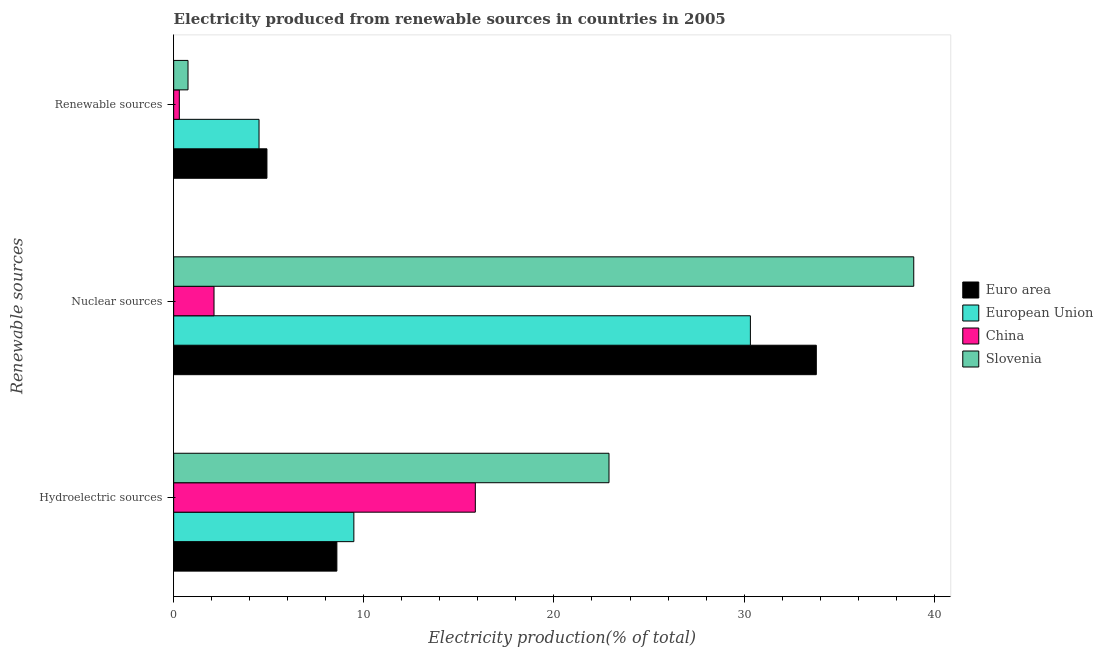How many different coloured bars are there?
Offer a very short reply. 4. How many groups of bars are there?
Provide a succinct answer. 3. How many bars are there on the 2nd tick from the top?
Provide a succinct answer. 4. What is the label of the 2nd group of bars from the top?
Your response must be concise. Nuclear sources. What is the percentage of electricity produced by renewable sources in Slovenia?
Your answer should be very brief. 0.75. Across all countries, what is the maximum percentage of electricity produced by nuclear sources?
Provide a succinct answer. 38.92. Across all countries, what is the minimum percentage of electricity produced by hydroelectric sources?
Ensure brevity in your answer.  8.58. In which country was the percentage of electricity produced by hydroelectric sources maximum?
Ensure brevity in your answer.  Slovenia. What is the total percentage of electricity produced by hydroelectric sources in the graph?
Your answer should be very brief. 56.82. What is the difference between the percentage of electricity produced by nuclear sources in Euro area and that in Slovenia?
Offer a very short reply. -5.12. What is the difference between the percentage of electricity produced by nuclear sources in European Union and the percentage of electricity produced by hydroelectric sources in China?
Make the answer very short. 14.47. What is the average percentage of electricity produced by renewable sources per country?
Your answer should be compact. 2.61. What is the difference between the percentage of electricity produced by renewable sources and percentage of electricity produced by nuclear sources in Slovenia?
Provide a succinct answer. -38.17. What is the ratio of the percentage of electricity produced by nuclear sources in Euro area to that in Slovenia?
Give a very brief answer. 0.87. What is the difference between the highest and the second highest percentage of electricity produced by renewable sources?
Give a very brief answer. 0.42. What is the difference between the highest and the lowest percentage of electricity produced by nuclear sources?
Your answer should be very brief. 36.8. What does the 1st bar from the top in Nuclear sources represents?
Your answer should be compact. Slovenia. How many bars are there?
Your response must be concise. 12. Are all the bars in the graph horizontal?
Your answer should be compact. Yes. What is the difference between two consecutive major ticks on the X-axis?
Provide a short and direct response. 10. Does the graph contain any zero values?
Give a very brief answer. No. How are the legend labels stacked?
Ensure brevity in your answer.  Vertical. What is the title of the graph?
Offer a very short reply. Electricity produced from renewable sources in countries in 2005. What is the label or title of the Y-axis?
Offer a terse response. Renewable sources. What is the Electricity production(% of total) in Euro area in Hydroelectric sources?
Make the answer very short. 8.58. What is the Electricity production(% of total) in European Union in Hydroelectric sources?
Provide a succinct answer. 9.48. What is the Electricity production(% of total) of China in Hydroelectric sources?
Your answer should be compact. 15.86. What is the Electricity production(% of total) in Slovenia in Hydroelectric sources?
Your answer should be very brief. 22.89. What is the Electricity production(% of total) of Euro area in Nuclear sources?
Offer a very short reply. 33.8. What is the Electricity production(% of total) in European Union in Nuclear sources?
Your answer should be compact. 30.33. What is the Electricity production(% of total) in China in Nuclear sources?
Keep it short and to the point. 2.12. What is the Electricity production(% of total) in Slovenia in Nuclear sources?
Your answer should be compact. 38.92. What is the Electricity production(% of total) of Euro area in Renewable sources?
Your answer should be very brief. 4.91. What is the Electricity production(% of total) of European Union in Renewable sources?
Offer a very short reply. 4.49. What is the Electricity production(% of total) of China in Renewable sources?
Your answer should be very brief. 0.3. What is the Electricity production(% of total) of Slovenia in Renewable sources?
Provide a short and direct response. 0.75. Across all Renewable sources, what is the maximum Electricity production(% of total) of Euro area?
Provide a short and direct response. 33.8. Across all Renewable sources, what is the maximum Electricity production(% of total) of European Union?
Ensure brevity in your answer.  30.33. Across all Renewable sources, what is the maximum Electricity production(% of total) in China?
Give a very brief answer. 15.86. Across all Renewable sources, what is the maximum Electricity production(% of total) in Slovenia?
Offer a terse response. 38.92. Across all Renewable sources, what is the minimum Electricity production(% of total) of Euro area?
Offer a terse response. 4.91. Across all Renewable sources, what is the minimum Electricity production(% of total) of European Union?
Ensure brevity in your answer.  4.49. Across all Renewable sources, what is the minimum Electricity production(% of total) in China?
Your answer should be compact. 0.3. Across all Renewable sources, what is the minimum Electricity production(% of total) of Slovenia?
Make the answer very short. 0.75. What is the total Electricity production(% of total) in Euro area in the graph?
Offer a very short reply. 47.29. What is the total Electricity production(% of total) in European Union in the graph?
Ensure brevity in your answer.  44.3. What is the total Electricity production(% of total) of China in the graph?
Provide a succinct answer. 18.28. What is the total Electricity production(% of total) in Slovenia in the graph?
Provide a succinct answer. 62.57. What is the difference between the Electricity production(% of total) in Euro area in Hydroelectric sources and that in Nuclear sources?
Your response must be concise. -25.22. What is the difference between the Electricity production(% of total) in European Union in Hydroelectric sources and that in Nuclear sources?
Provide a short and direct response. -20.85. What is the difference between the Electricity production(% of total) in China in Hydroelectric sources and that in Nuclear sources?
Your response must be concise. 13.74. What is the difference between the Electricity production(% of total) of Slovenia in Hydroelectric sources and that in Nuclear sources?
Ensure brevity in your answer.  -16.03. What is the difference between the Electricity production(% of total) of Euro area in Hydroelectric sources and that in Renewable sources?
Offer a terse response. 3.68. What is the difference between the Electricity production(% of total) of European Union in Hydroelectric sources and that in Renewable sources?
Your answer should be compact. 4.99. What is the difference between the Electricity production(% of total) of China in Hydroelectric sources and that in Renewable sources?
Keep it short and to the point. 15.57. What is the difference between the Electricity production(% of total) in Slovenia in Hydroelectric sources and that in Renewable sources?
Provide a succinct answer. 22.14. What is the difference between the Electricity production(% of total) in Euro area in Nuclear sources and that in Renewable sources?
Your answer should be very brief. 28.89. What is the difference between the Electricity production(% of total) of European Union in Nuclear sources and that in Renewable sources?
Your response must be concise. 25.84. What is the difference between the Electricity production(% of total) of China in Nuclear sources and that in Renewable sources?
Ensure brevity in your answer.  1.82. What is the difference between the Electricity production(% of total) in Slovenia in Nuclear sources and that in Renewable sources?
Offer a very short reply. 38.17. What is the difference between the Electricity production(% of total) of Euro area in Hydroelectric sources and the Electricity production(% of total) of European Union in Nuclear sources?
Keep it short and to the point. -21.75. What is the difference between the Electricity production(% of total) in Euro area in Hydroelectric sources and the Electricity production(% of total) in China in Nuclear sources?
Provide a short and direct response. 6.46. What is the difference between the Electricity production(% of total) in Euro area in Hydroelectric sources and the Electricity production(% of total) in Slovenia in Nuclear sources?
Offer a terse response. -30.34. What is the difference between the Electricity production(% of total) in European Union in Hydroelectric sources and the Electricity production(% of total) in China in Nuclear sources?
Keep it short and to the point. 7.36. What is the difference between the Electricity production(% of total) of European Union in Hydroelectric sources and the Electricity production(% of total) of Slovenia in Nuclear sources?
Offer a very short reply. -29.45. What is the difference between the Electricity production(% of total) of China in Hydroelectric sources and the Electricity production(% of total) of Slovenia in Nuclear sources?
Offer a terse response. -23.06. What is the difference between the Electricity production(% of total) of Euro area in Hydroelectric sources and the Electricity production(% of total) of European Union in Renewable sources?
Ensure brevity in your answer.  4.09. What is the difference between the Electricity production(% of total) of Euro area in Hydroelectric sources and the Electricity production(% of total) of China in Renewable sources?
Provide a short and direct response. 8.29. What is the difference between the Electricity production(% of total) in Euro area in Hydroelectric sources and the Electricity production(% of total) in Slovenia in Renewable sources?
Make the answer very short. 7.83. What is the difference between the Electricity production(% of total) in European Union in Hydroelectric sources and the Electricity production(% of total) in China in Renewable sources?
Your response must be concise. 9.18. What is the difference between the Electricity production(% of total) in European Union in Hydroelectric sources and the Electricity production(% of total) in Slovenia in Renewable sources?
Ensure brevity in your answer.  8.72. What is the difference between the Electricity production(% of total) of China in Hydroelectric sources and the Electricity production(% of total) of Slovenia in Renewable sources?
Give a very brief answer. 15.11. What is the difference between the Electricity production(% of total) of Euro area in Nuclear sources and the Electricity production(% of total) of European Union in Renewable sources?
Provide a succinct answer. 29.31. What is the difference between the Electricity production(% of total) in Euro area in Nuclear sources and the Electricity production(% of total) in China in Renewable sources?
Offer a terse response. 33.5. What is the difference between the Electricity production(% of total) in Euro area in Nuclear sources and the Electricity production(% of total) in Slovenia in Renewable sources?
Your answer should be compact. 33.04. What is the difference between the Electricity production(% of total) of European Union in Nuclear sources and the Electricity production(% of total) of China in Renewable sources?
Offer a very short reply. 30.03. What is the difference between the Electricity production(% of total) of European Union in Nuclear sources and the Electricity production(% of total) of Slovenia in Renewable sources?
Keep it short and to the point. 29.58. What is the difference between the Electricity production(% of total) of China in Nuclear sources and the Electricity production(% of total) of Slovenia in Renewable sources?
Give a very brief answer. 1.37. What is the average Electricity production(% of total) of Euro area per Renewable sources?
Give a very brief answer. 15.76. What is the average Electricity production(% of total) of European Union per Renewable sources?
Keep it short and to the point. 14.77. What is the average Electricity production(% of total) of China per Renewable sources?
Offer a very short reply. 6.09. What is the average Electricity production(% of total) in Slovenia per Renewable sources?
Offer a very short reply. 20.86. What is the difference between the Electricity production(% of total) in Euro area and Electricity production(% of total) in European Union in Hydroelectric sources?
Give a very brief answer. -0.89. What is the difference between the Electricity production(% of total) in Euro area and Electricity production(% of total) in China in Hydroelectric sources?
Give a very brief answer. -7.28. What is the difference between the Electricity production(% of total) in Euro area and Electricity production(% of total) in Slovenia in Hydroelectric sources?
Keep it short and to the point. -14.31. What is the difference between the Electricity production(% of total) of European Union and Electricity production(% of total) of China in Hydroelectric sources?
Give a very brief answer. -6.39. What is the difference between the Electricity production(% of total) of European Union and Electricity production(% of total) of Slovenia in Hydroelectric sources?
Provide a succinct answer. -13.42. What is the difference between the Electricity production(% of total) in China and Electricity production(% of total) in Slovenia in Hydroelectric sources?
Provide a succinct answer. -7.03. What is the difference between the Electricity production(% of total) in Euro area and Electricity production(% of total) in European Union in Nuclear sources?
Provide a short and direct response. 3.47. What is the difference between the Electricity production(% of total) of Euro area and Electricity production(% of total) of China in Nuclear sources?
Make the answer very short. 31.68. What is the difference between the Electricity production(% of total) of Euro area and Electricity production(% of total) of Slovenia in Nuclear sources?
Ensure brevity in your answer.  -5.12. What is the difference between the Electricity production(% of total) of European Union and Electricity production(% of total) of China in Nuclear sources?
Ensure brevity in your answer.  28.21. What is the difference between the Electricity production(% of total) of European Union and Electricity production(% of total) of Slovenia in Nuclear sources?
Ensure brevity in your answer.  -8.59. What is the difference between the Electricity production(% of total) in China and Electricity production(% of total) in Slovenia in Nuclear sources?
Your answer should be very brief. -36.8. What is the difference between the Electricity production(% of total) in Euro area and Electricity production(% of total) in European Union in Renewable sources?
Your answer should be very brief. 0.42. What is the difference between the Electricity production(% of total) in Euro area and Electricity production(% of total) in China in Renewable sources?
Your answer should be compact. 4.61. What is the difference between the Electricity production(% of total) of Euro area and Electricity production(% of total) of Slovenia in Renewable sources?
Keep it short and to the point. 4.15. What is the difference between the Electricity production(% of total) in European Union and Electricity production(% of total) in China in Renewable sources?
Offer a very short reply. 4.19. What is the difference between the Electricity production(% of total) in European Union and Electricity production(% of total) in Slovenia in Renewable sources?
Ensure brevity in your answer.  3.74. What is the difference between the Electricity production(% of total) of China and Electricity production(% of total) of Slovenia in Renewable sources?
Give a very brief answer. -0.46. What is the ratio of the Electricity production(% of total) of Euro area in Hydroelectric sources to that in Nuclear sources?
Provide a short and direct response. 0.25. What is the ratio of the Electricity production(% of total) of European Union in Hydroelectric sources to that in Nuclear sources?
Your response must be concise. 0.31. What is the ratio of the Electricity production(% of total) in China in Hydroelectric sources to that in Nuclear sources?
Give a very brief answer. 7.48. What is the ratio of the Electricity production(% of total) in Slovenia in Hydroelectric sources to that in Nuclear sources?
Make the answer very short. 0.59. What is the ratio of the Electricity production(% of total) of Euro area in Hydroelectric sources to that in Renewable sources?
Offer a very short reply. 1.75. What is the ratio of the Electricity production(% of total) in European Union in Hydroelectric sources to that in Renewable sources?
Ensure brevity in your answer.  2.11. What is the ratio of the Electricity production(% of total) in China in Hydroelectric sources to that in Renewable sources?
Offer a terse response. 53.38. What is the ratio of the Electricity production(% of total) of Slovenia in Hydroelectric sources to that in Renewable sources?
Keep it short and to the point. 30.36. What is the ratio of the Electricity production(% of total) in Euro area in Nuclear sources to that in Renewable sources?
Your response must be concise. 6.89. What is the ratio of the Electricity production(% of total) of European Union in Nuclear sources to that in Renewable sources?
Offer a terse response. 6.76. What is the ratio of the Electricity production(% of total) of China in Nuclear sources to that in Renewable sources?
Provide a short and direct response. 7.14. What is the ratio of the Electricity production(% of total) of Slovenia in Nuclear sources to that in Renewable sources?
Keep it short and to the point. 51.61. What is the difference between the highest and the second highest Electricity production(% of total) of Euro area?
Your answer should be very brief. 25.22. What is the difference between the highest and the second highest Electricity production(% of total) of European Union?
Ensure brevity in your answer.  20.85. What is the difference between the highest and the second highest Electricity production(% of total) in China?
Your answer should be very brief. 13.74. What is the difference between the highest and the second highest Electricity production(% of total) in Slovenia?
Give a very brief answer. 16.03. What is the difference between the highest and the lowest Electricity production(% of total) in Euro area?
Give a very brief answer. 28.89. What is the difference between the highest and the lowest Electricity production(% of total) in European Union?
Ensure brevity in your answer.  25.84. What is the difference between the highest and the lowest Electricity production(% of total) of China?
Make the answer very short. 15.57. What is the difference between the highest and the lowest Electricity production(% of total) of Slovenia?
Provide a short and direct response. 38.17. 